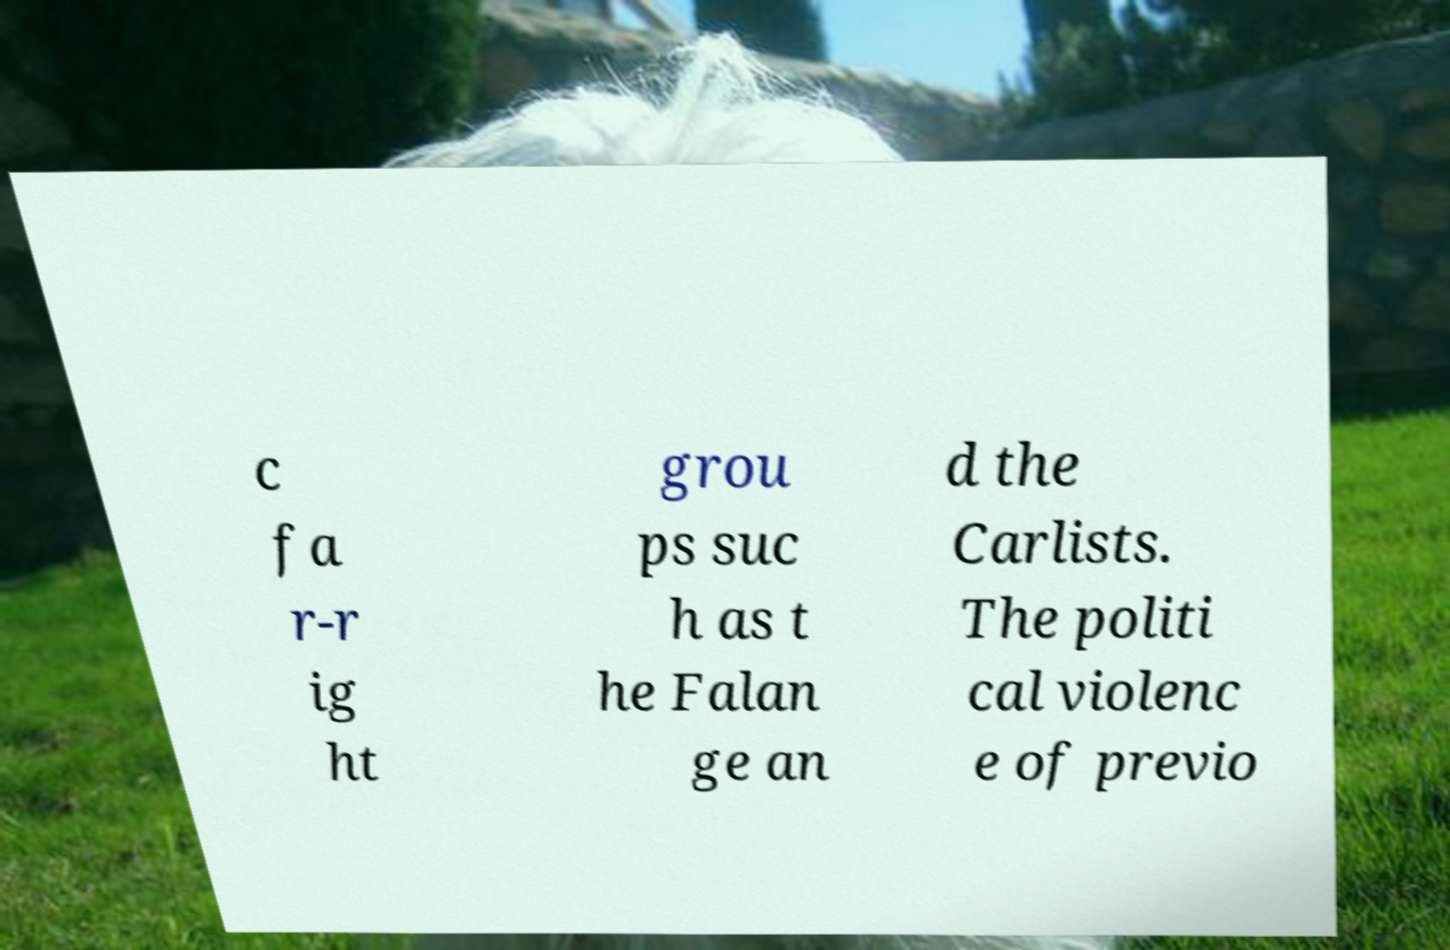Please read and relay the text visible in this image. What does it say? c fa r-r ig ht grou ps suc h as t he Falan ge an d the Carlists. The politi cal violenc e of previo 